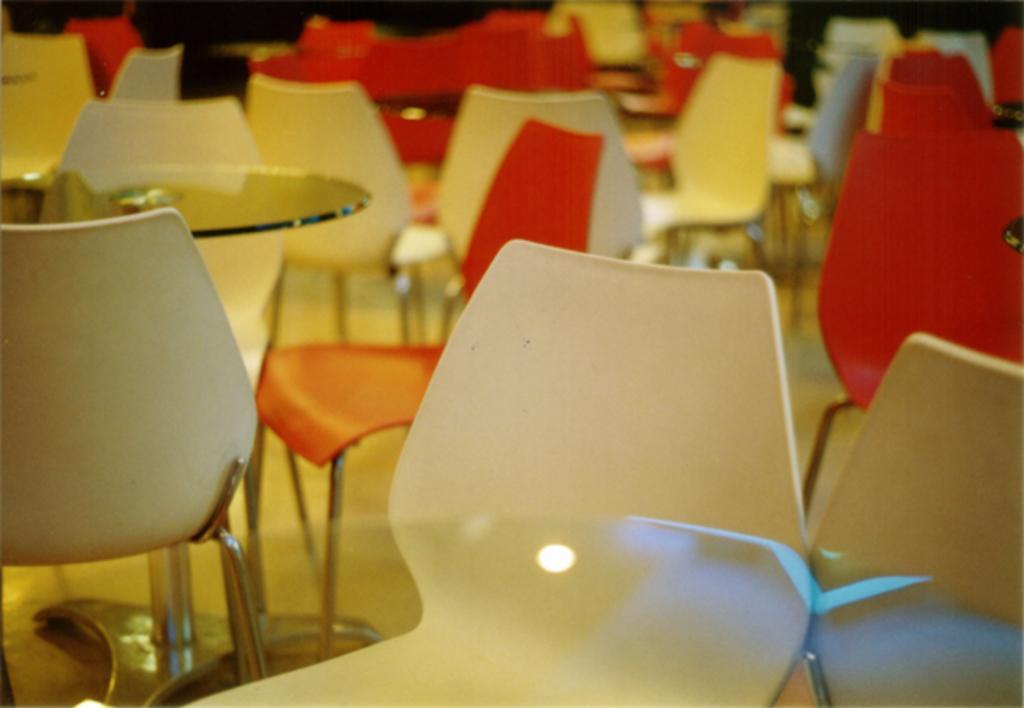Can you describe this image briefly? In this image there are red chairs, white chairs and glass tables. 